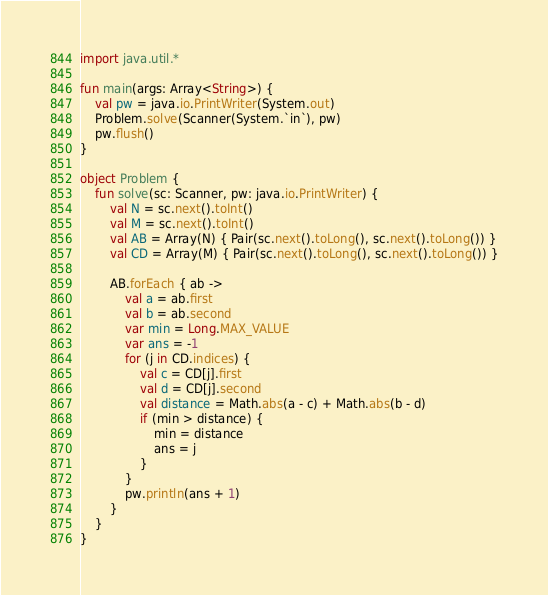Convert code to text. <code><loc_0><loc_0><loc_500><loc_500><_Kotlin_>import java.util.*

fun main(args: Array<String>) {
    val pw = java.io.PrintWriter(System.out)
    Problem.solve(Scanner(System.`in`), pw)
    pw.flush()
}

object Problem {
    fun solve(sc: Scanner, pw: java.io.PrintWriter) {
        val N = sc.next().toInt()
        val M = sc.next().toInt()
        val AB = Array(N) { Pair(sc.next().toLong(), sc.next().toLong()) }
        val CD = Array(M) { Pair(sc.next().toLong(), sc.next().toLong()) }

        AB.forEach { ab ->
            val a = ab.first
            val b = ab.second
            var min = Long.MAX_VALUE
            var ans = -1
            for (j in CD.indices) {
                val c = CD[j].first
                val d = CD[j].second
                val distance = Math.abs(a - c) + Math.abs(b - d)
                if (min > distance) {
                    min = distance
                    ans = j
                }
            }
            pw.println(ans + 1)
        }
    }
}
</code> 